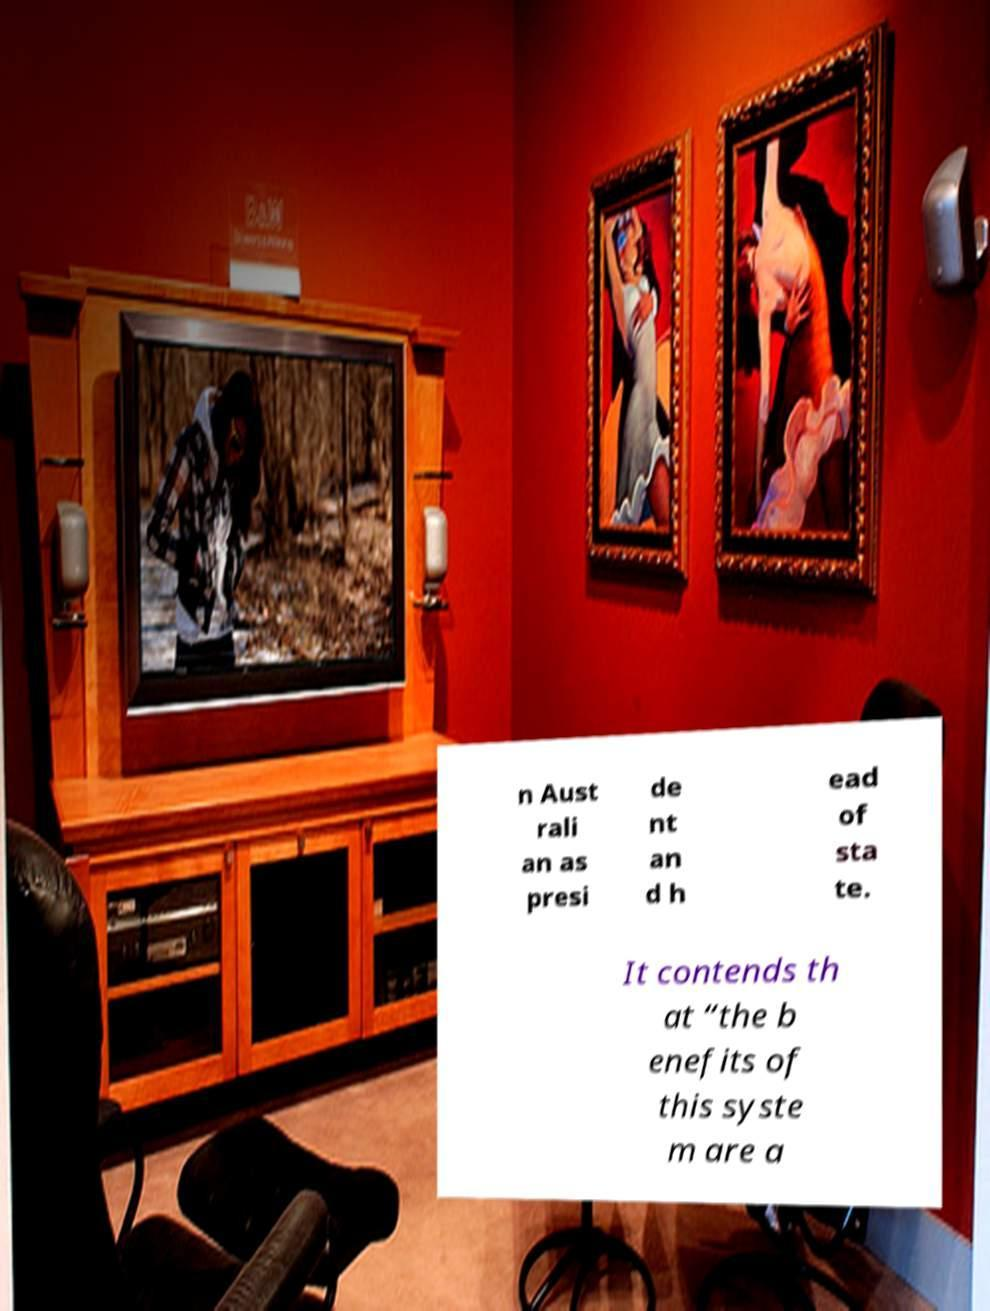I need the written content from this picture converted into text. Can you do that? n Aust rali an as presi de nt an d h ead of sta te. It contends th at “the b enefits of this syste m are a 